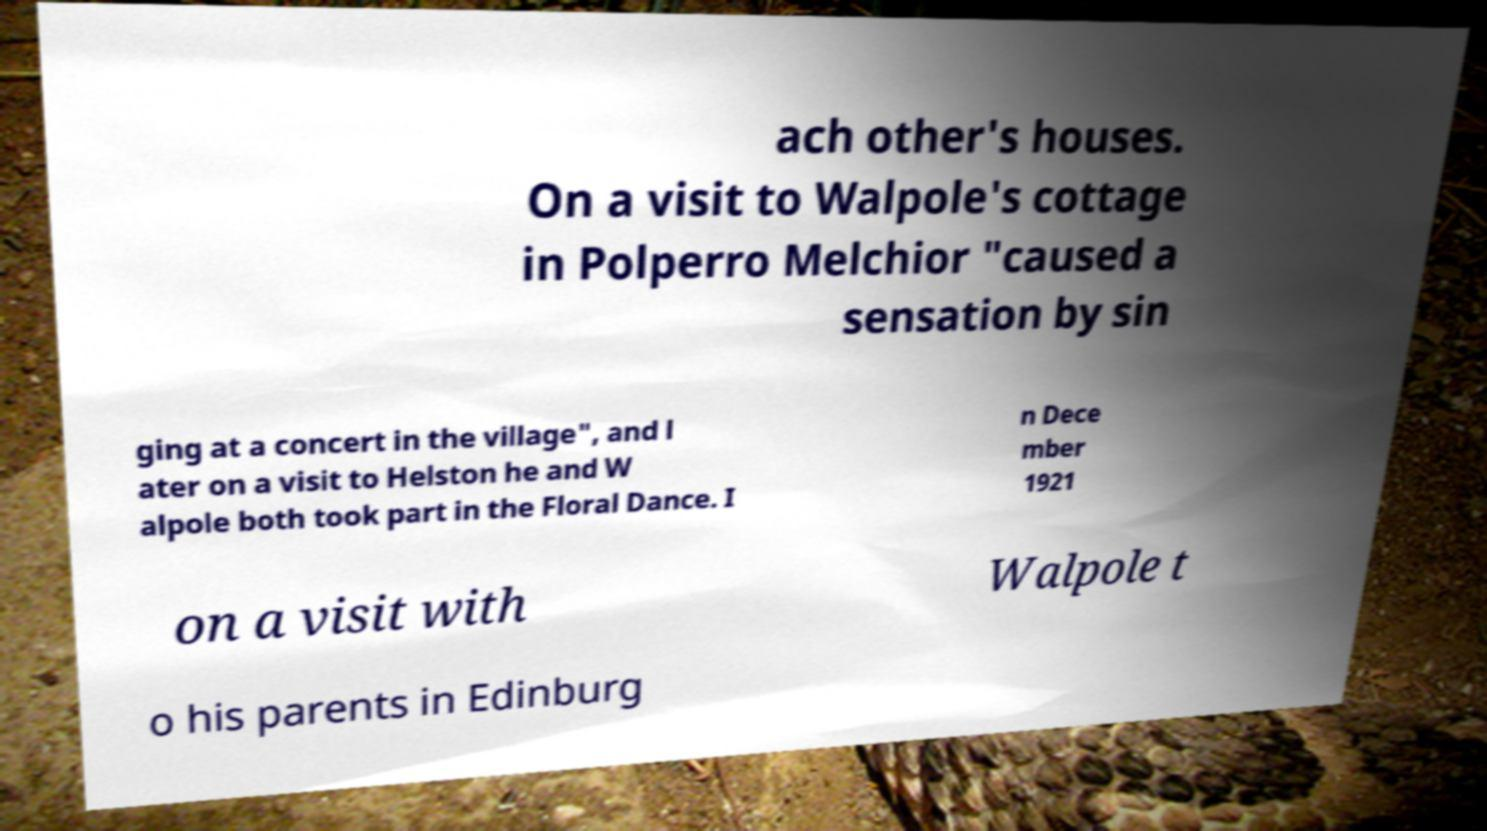What messages or text are displayed in this image? I need them in a readable, typed format. ach other's houses. On a visit to Walpole's cottage in Polperro Melchior "caused a sensation by sin ging at a concert in the village", and l ater on a visit to Helston he and W alpole both took part in the Floral Dance. I n Dece mber 1921 on a visit with Walpole t o his parents in Edinburg 